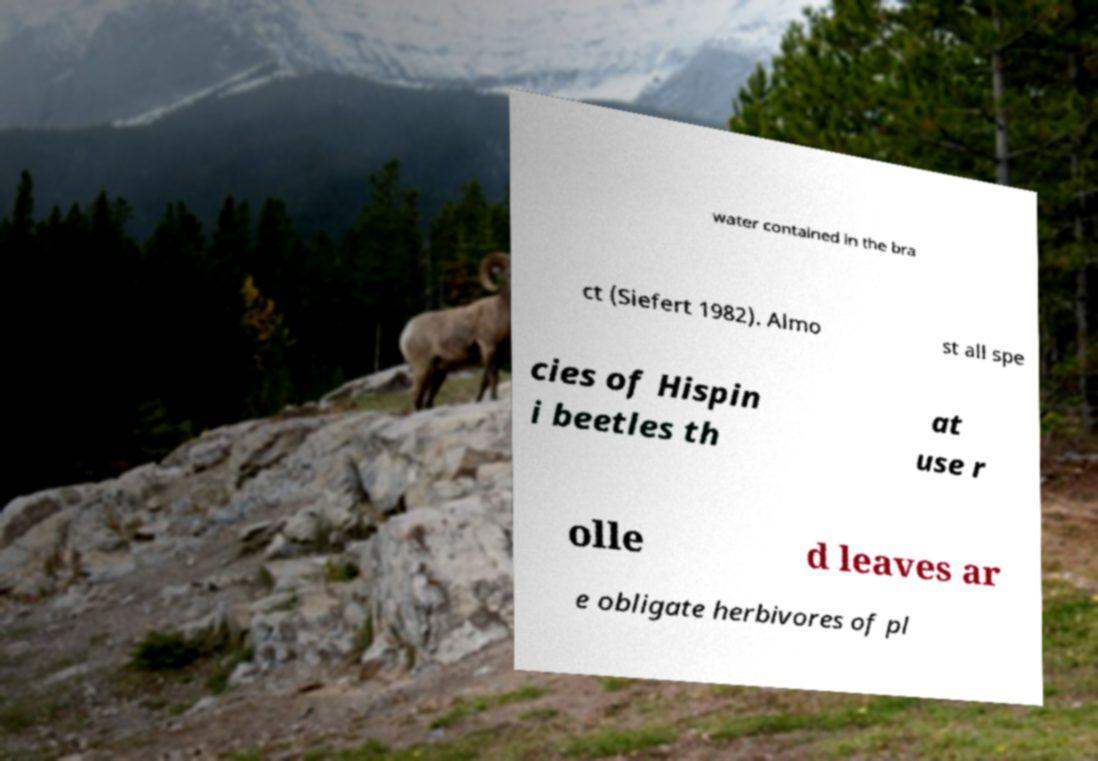Can you accurately transcribe the text from the provided image for me? water contained in the bra ct (Siefert 1982). Almo st all spe cies of Hispin i beetles th at use r olle d leaves ar e obligate herbivores of pl 